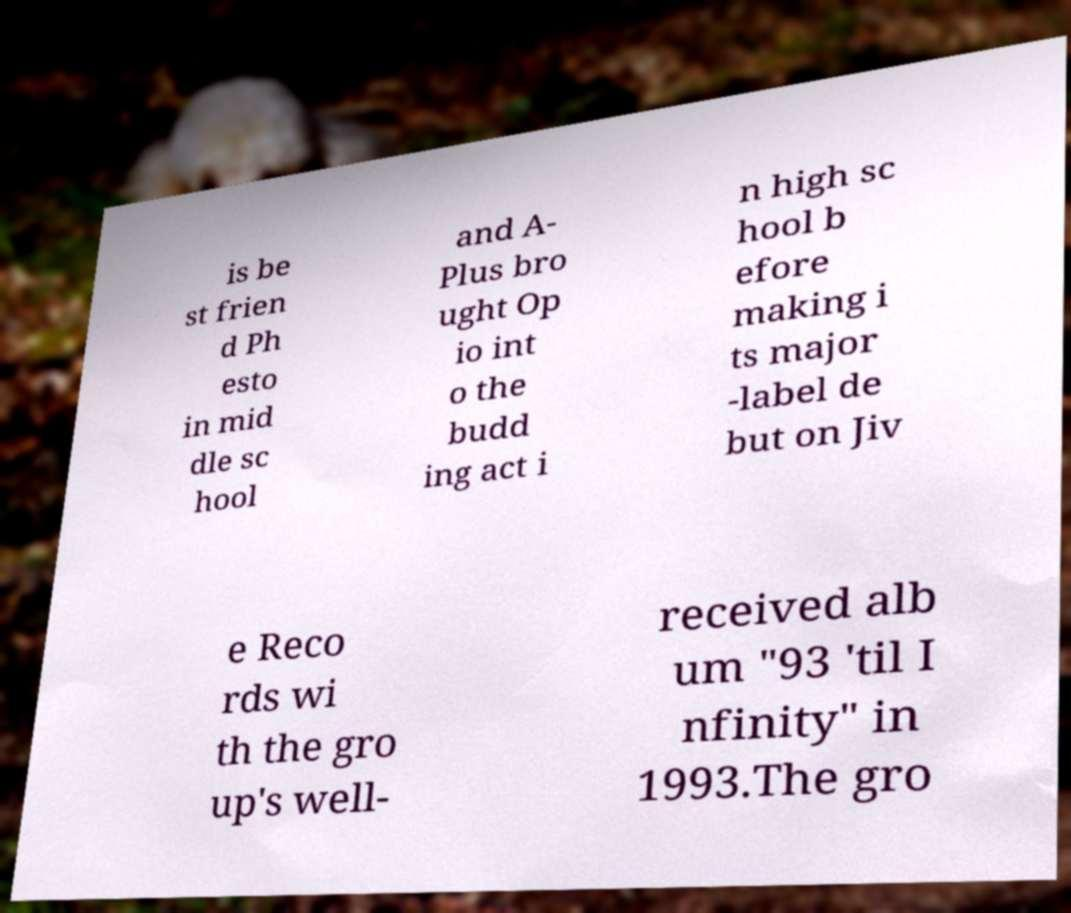Could you assist in decoding the text presented in this image and type it out clearly? is be st frien d Ph esto in mid dle sc hool and A- Plus bro ught Op io int o the budd ing act i n high sc hool b efore making i ts major -label de but on Jiv e Reco rds wi th the gro up's well- received alb um "93 'til I nfinity" in 1993.The gro 